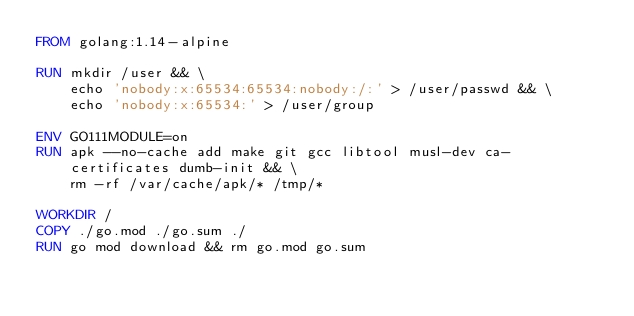Convert code to text. <code><loc_0><loc_0><loc_500><loc_500><_Dockerfile_>FROM golang:1.14-alpine

RUN mkdir /user && \
    echo 'nobody:x:65534:65534:nobody:/:' > /user/passwd && \
    echo 'nobody:x:65534:' > /user/group

ENV GO111MODULE=on
RUN apk --no-cache add make git gcc libtool musl-dev ca-certificates dumb-init && \
    rm -rf /var/cache/apk/* /tmp/*

WORKDIR /
COPY ./go.mod ./go.sum ./
RUN go mod download && rm go.mod go.sum
</code> 